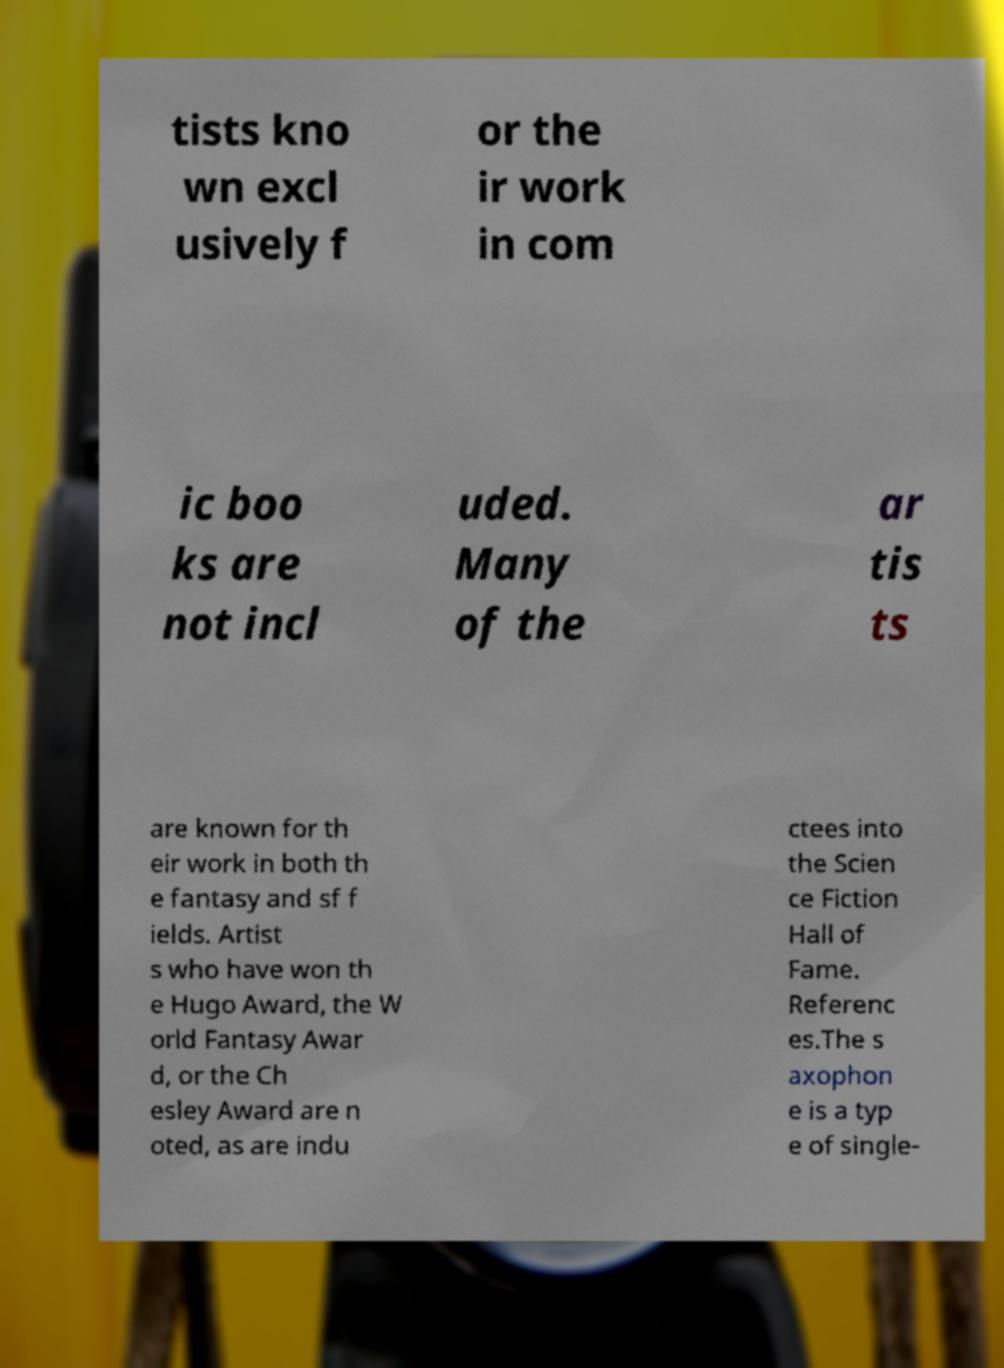Please read and relay the text visible in this image. What does it say? tists kno wn excl usively f or the ir work in com ic boo ks are not incl uded. Many of the ar tis ts are known for th eir work in both th e fantasy and sf f ields. Artist s who have won th e Hugo Award, the W orld Fantasy Awar d, or the Ch esley Award are n oted, as are indu ctees into the Scien ce Fiction Hall of Fame. Referenc es.The s axophon e is a typ e of single- 